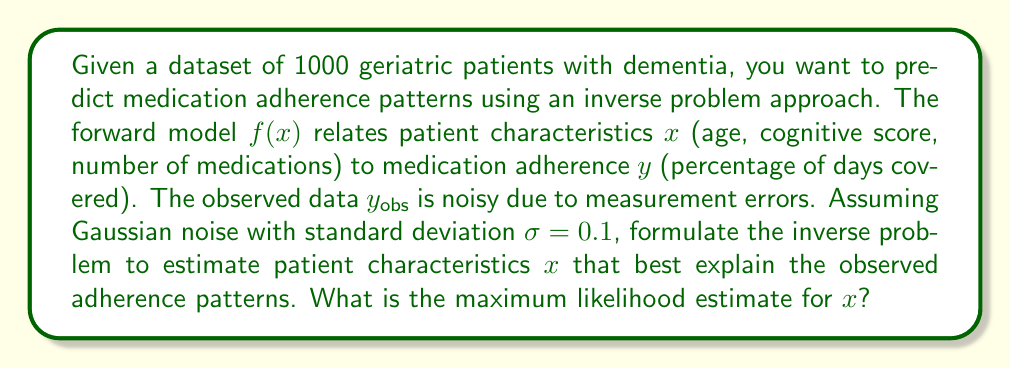What is the answer to this math problem? To solve this inverse problem, we need to follow these steps:

1) The forward model is given by $f(x)$, where $x$ represents patient characteristics and $y$ represents medication adherence.

2) The observed data $y_{obs}$ is related to the true adherence $y$ by:

   $y_{obs} = y + \epsilon$, where $\epsilon \sim N(0, \sigma^2)$

3) The likelihood function for a single observation is:

   $P(y_{obs}|x) = \frac{1}{\sqrt{2\pi\sigma^2}} \exp(-\frac{(y_{obs} - f(x))^2}{2\sigma^2})$

4) For all observations, the likelihood is:

   $L(x) = \prod_{i=1}^n P(y_{obs,i}|x)$

5) Taking the logarithm, we get the log-likelihood:

   $\ln L(x) = -\frac{n}{2}\ln(2\pi\sigma^2) - \frac{1}{2\sigma^2}\sum_{i=1}^n (y_{obs,i} - f(x))^2$

6) The maximum likelihood estimate (MLE) is found by maximizing the log-likelihood:

   $\hat{x}_{MLE} = \arg\max_x \ln L(x)$

7) This is equivalent to minimizing the sum of squared residuals:

   $\hat{x}_{MLE} = \arg\min_x \sum_{i=1}^n (y_{obs,i} - f(x))^2$

8) This minimization problem can be solved using optimization techniques such as gradient descent or Gauss-Newton method, depending on the specific form of $f(x)$.
Answer: $\hat{x}_{MLE} = \arg\min_x \sum_{i=1}^n (y_{obs,i} - f(x))^2$ 